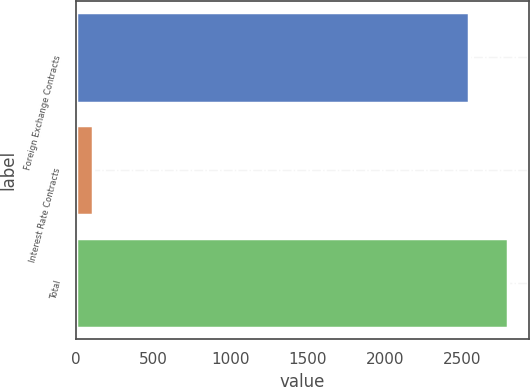Convert chart to OTSL. <chart><loc_0><loc_0><loc_500><loc_500><bar_chart><fcel>Foreign Exchange Contracts<fcel>Interest Rate Contracts<fcel>Total<nl><fcel>2541.8<fcel>111.1<fcel>2795.98<nl></chart> 